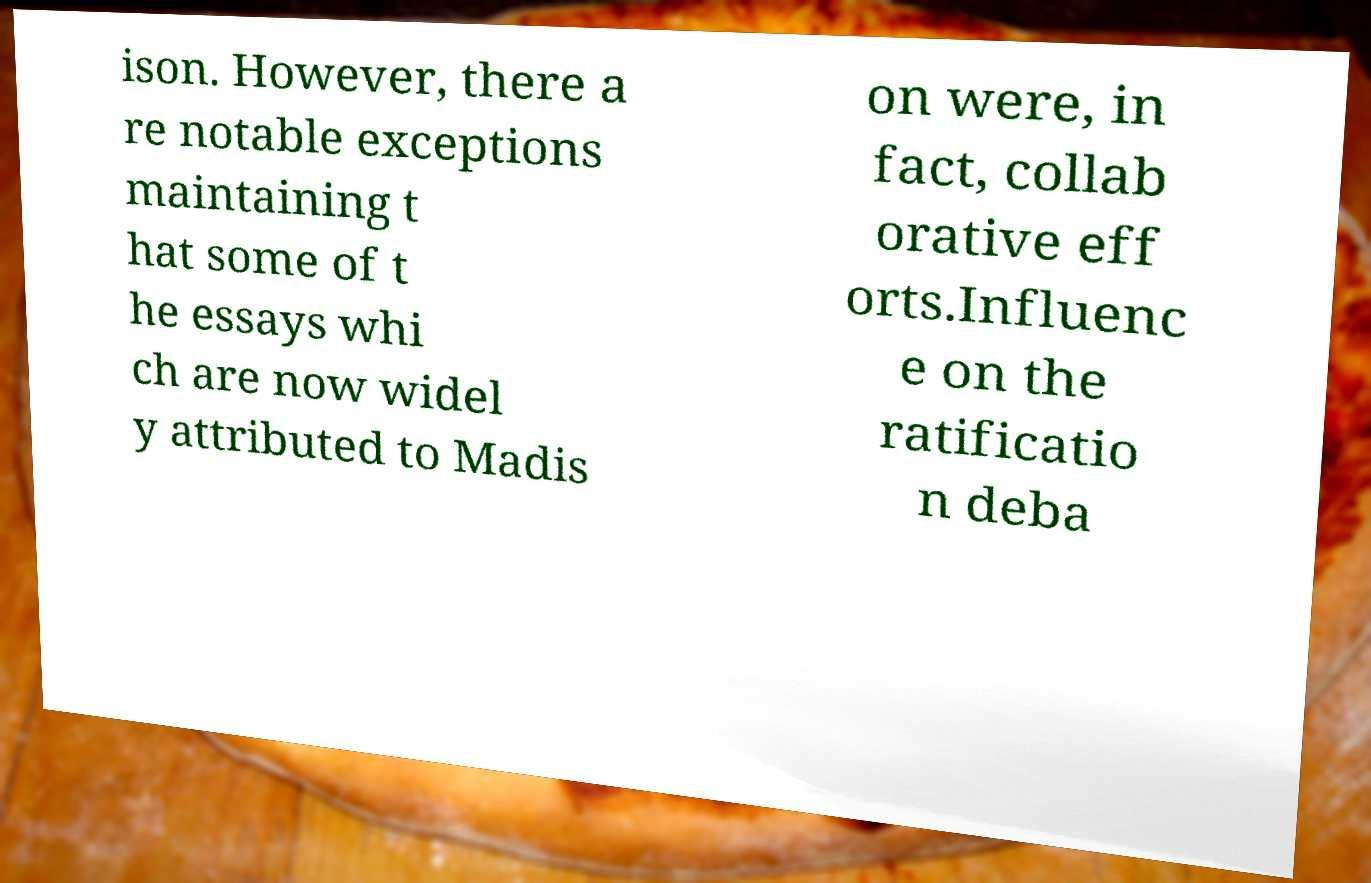I need the written content from this picture converted into text. Can you do that? ison. However, there a re notable exceptions maintaining t hat some of t he essays whi ch are now widel y attributed to Madis on were, in fact, collab orative eff orts.Influenc e on the ratificatio n deba 